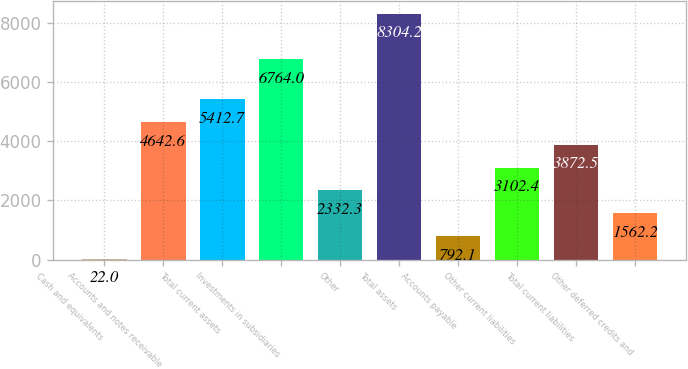<chart> <loc_0><loc_0><loc_500><loc_500><bar_chart><fcel>Cash and equivalents<fcel>Accounts and notes receivable<fcel>Total current assets<fcel>Investments in subsidiaries<fcel>Other<fcel>Total assets<fcel>Accounts payable<fcel>Other current liabilities<fcel>Total current liabilities<fcel>Other deferred credits and<nl><fcel>22<fcel>4642.6<fcel>5412.7<fcel>6764<fcel>2332.3<fcel>8304.2<fcel>792.1<fcel>3102.4<fcel>3872.5<fcel>1562.2<nl></chart> 